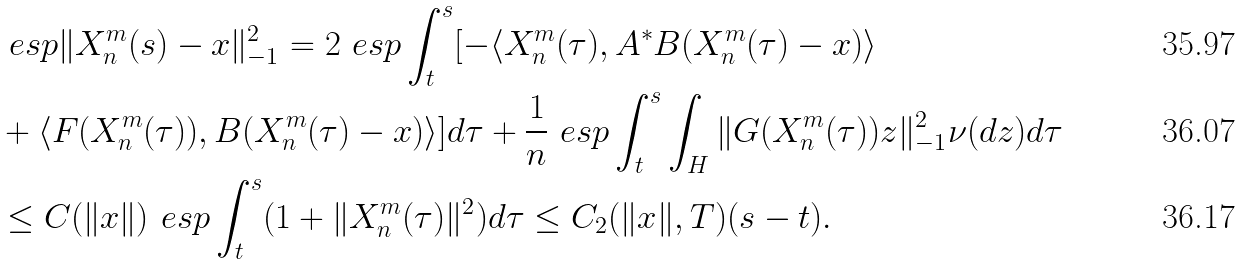Convert formula to latex. <formula><loc_0><loc_0><loc_500><loc_500>& \ e s p \| X _ { n } ^ { m } ( s ) - x \| _ { - 1 } ^ { 2 } = 2 \ e s p \int _ { t } ^ { s } [ - \langle X _ { n } ^ { m } ( \tau ) , A ^ { \ast } B ( X _ { n } ^ { m } ( \tau ) - x ) \rangle \\ & + \langle F ( X _ { n } ^ { m } ( \tau ) ) , B ( X _ { n } ^ { m } ( \tau ) - x ) \rangle ] d \tau + { \frac { 1 } { n } } \ e s p \int _ { t } ^ { s } \int _ { H } \| G ( X _ { n } ^ { m } ( \tau ) ) z \| _ { - 1 } ^ { 2 } \nu ( d z ) d \tau \\ & \leq C ( \| x \| ) \ e s p \int _ { t } ^ { s } ( 1 + \| X _ { n } ^ { m } ( \tau ) \| ^ { 2 } ) d \tau \leq C _ { 2 } ( \| x \| , T ) ( s - t ) .</formula> 